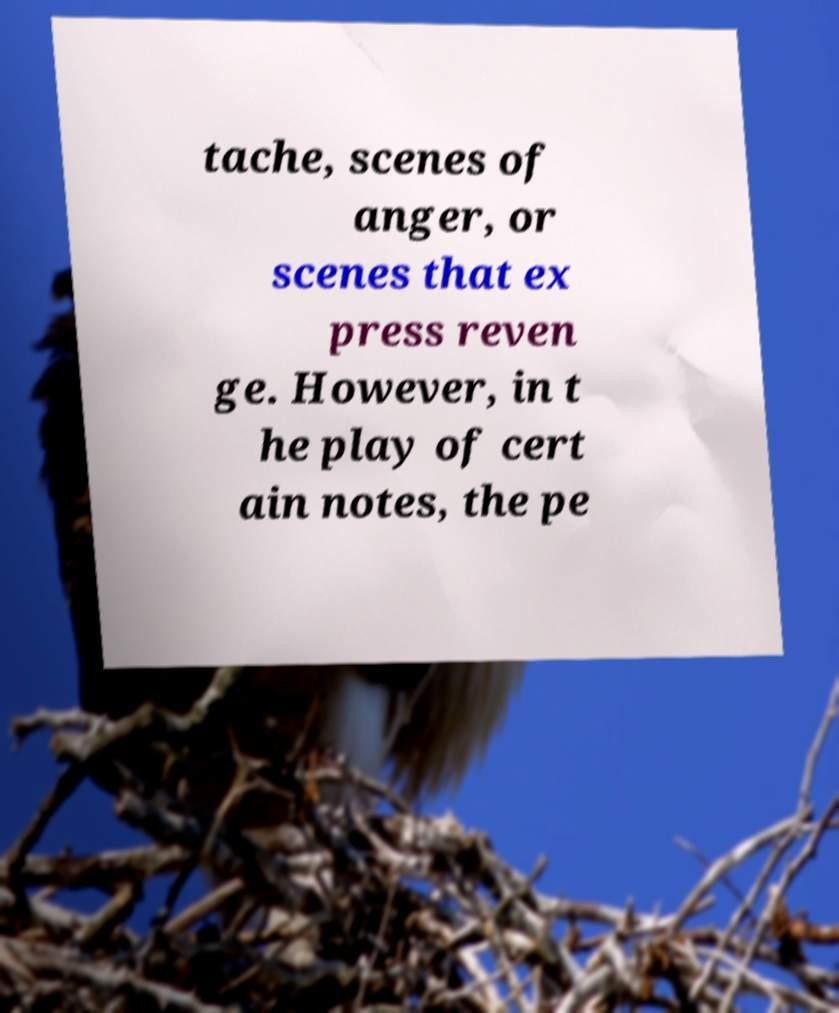For documentation purposes, I need the text within this image transcribed. Could you provide that? tache, scenes of anger, or scenes that ex press reven ge. However, in t he play of cert ain notes, the pe 